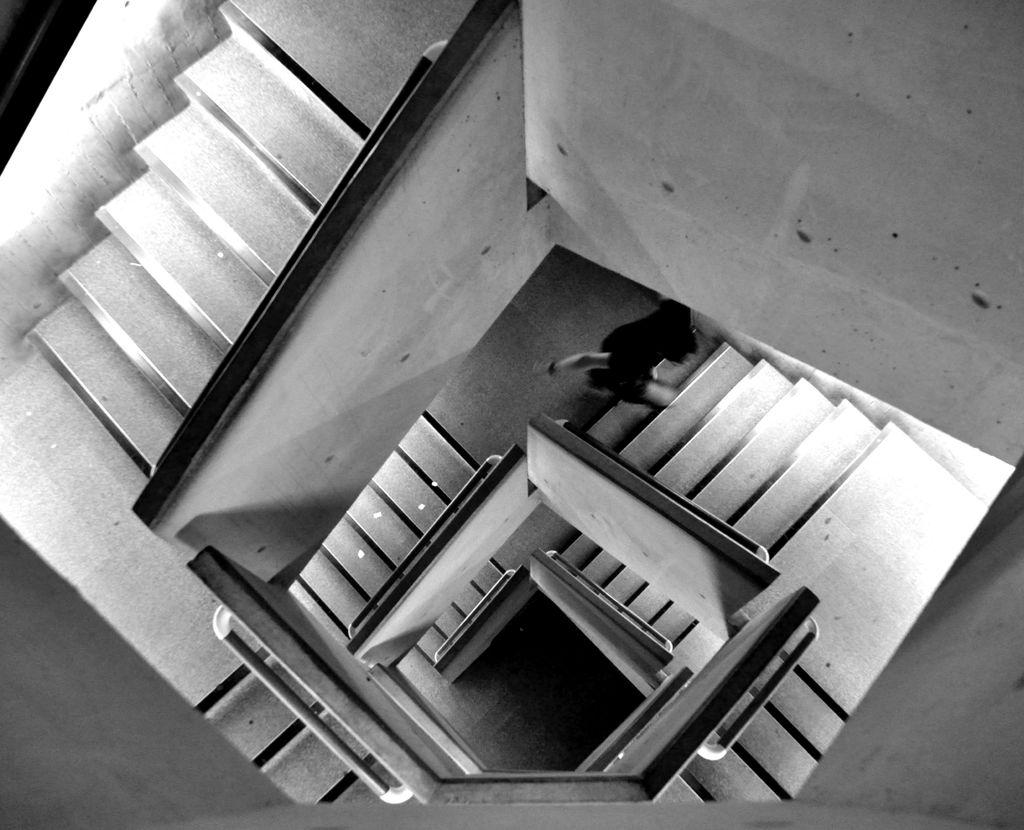What is the main subject of the picture? There is a person in the picture. What architectural feature is present in the image? There are stairs in the picture. What color scheme is used in the image? The picture is black and white in color. How many beds are visible in the image? There are no beds present in the image. What type of servant is attending to the person in the image? There is no servant present in the image, as it only features a person and stairs. 